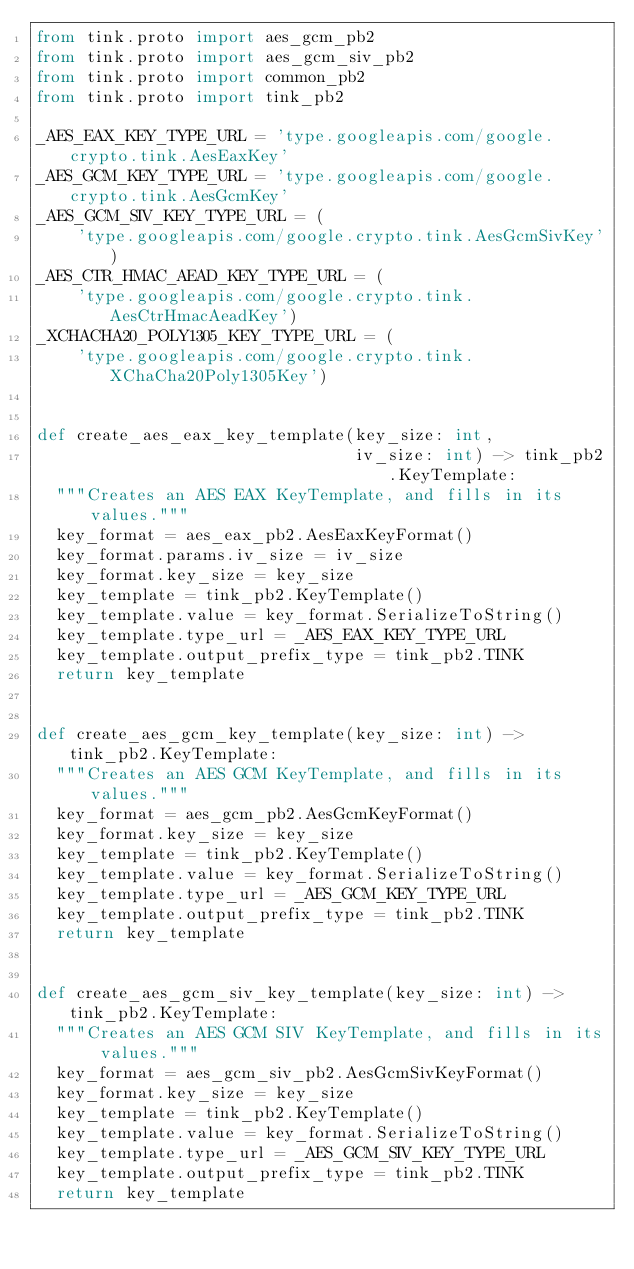<code> <loc_0><loc_0><loc_500><loc_500><_Python_>from tink.proto import aes_gcm_pb2
from tink.proto import aes_gcm_siv_pb2
from tink.proto import common_pb2
from tink.proto import tink_pb2

_AES_EAX_KEY_TYPE_URL = 'type.googleapis.com/google.crypto.tink.AesEaxKey'
_AES_GCM_KEY_TYPE_URL = 'type.googleapis.com/google.crypto.tink.AesGcmKey'
_AES_GCM_SIV_KEY_TYPE_URL = (
    'type.googleapis.com/google.crypto.tink.AesGcmSivKey')
_AES_CTR_HMAC_AEAD_KEY_TYPE_URL = (
    'type.googleapis.com/google.crypto.tink.AesCtrHmacAeadKey')
_XCHACHA20_POLY1305_KEY_TYPE_URL = (
    'type.googleapis.com/google.crypto.tink.XChaCha20Poly1305Key')


def create_aes_eax_key_template(key_size: int,
                                iv_size: int) -> tink_pb2.KeyTemplate:
  """Creates an AES EAX KeyTemplate, and fills in its values."""
  key_format = aes_eax_pb2.AesEaxKeyFormat()
  key_format.params.iv_size = iv_size
  key_format.key_size = key_size
  key_template = tink_pb2.KeyTemplate()
  key_template.value = key_format.SerializeToString()
  key_template.type_url = _AES_EAX_KEY_TYPE_URL
  key_template.output_prefix_type = tink_pb2.TINK
  return key_template


def create_aes_gcm_key_template(key_size: int) -> tink_pb2.KeyTemplate:
  """Creates an AES GCM KeyTemplate, and fills in its values."""
  key_format = aes_gcm_pb2.AesGcmKeyFormat()
  key_format.key_size = key_size
  key_template = tink_pb2.KeyTemplate()
  key_template.value = key_format.SerializeToString()
  key_template.type_url = _AES_GCM_KEY_TYPE_URL
  key_template.output_prefix_type = tink_pb2.TINK
  return key_template


def create_aes_gcm_siv_key_template(key_size: int) -> tink_pb2.KeyTemplate:
  """Creates an AES GCM SIV KeyTemplate, and fills in its values."""
  key_format = aes_gcm_siv_pb2.AesGcmSivKeyFormat()
  key_format.key_size = key_size
  key_template = tink_pb2.KeyTemplate()
  key_template.value = key_format.SerializeToString()
  key_template.type_url = _AES_GCM_SIV_KEY_TYPE_URL
  key_template.output_prefix_type = tink_pb2.TINK
  return key_template

</code> 